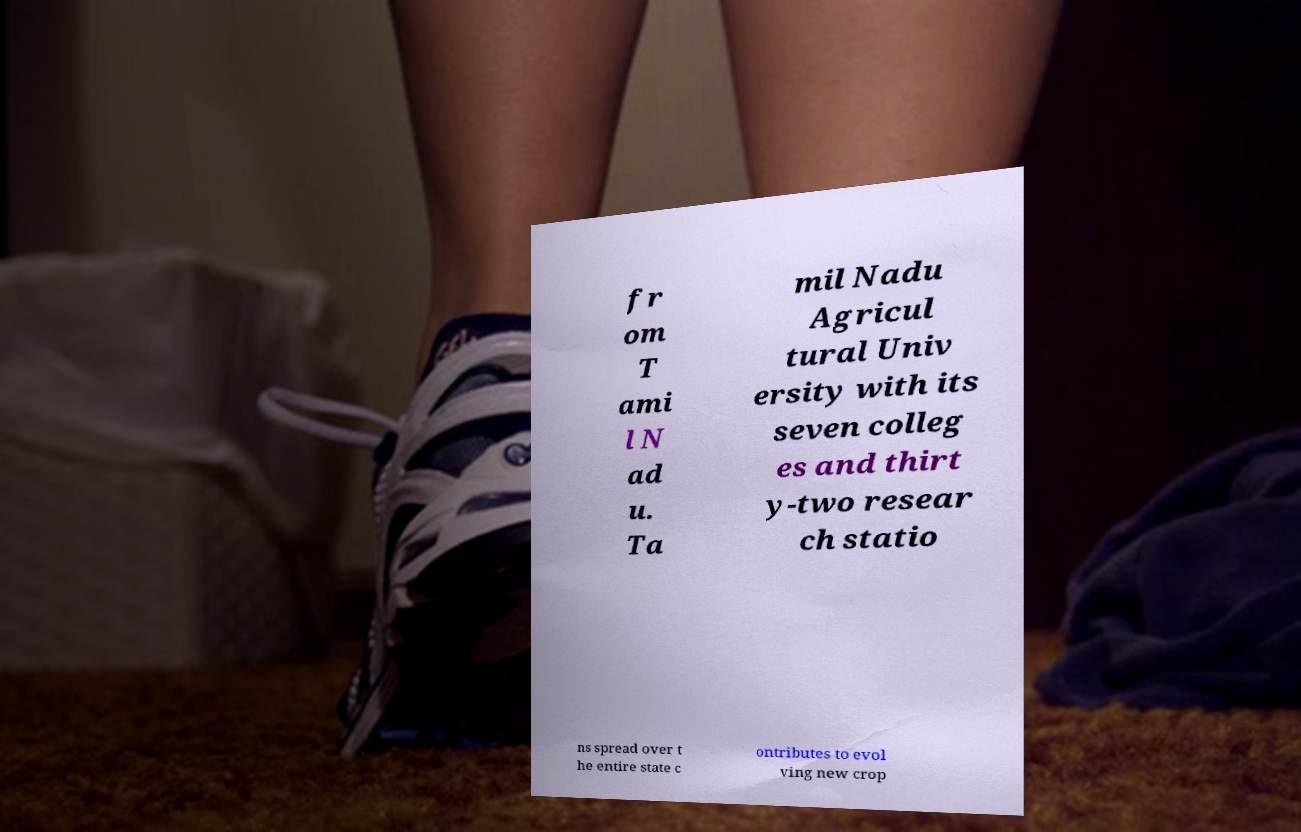Could you extract and type out the text from this image? fr om T ami l N ad u. Ta mil Nadu Agricul tural Univ ersity with its seven colleg es and thirt y-two resear ch statio ns spread over t he entire state c ontributes to evol ving new crop 